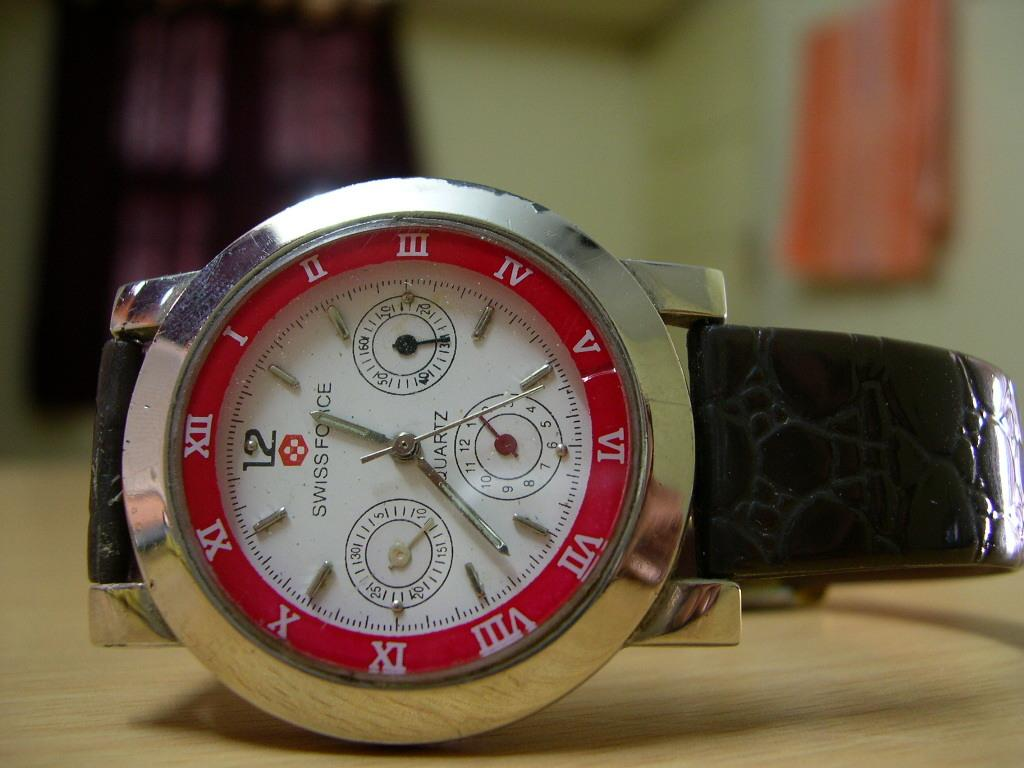<image>
Present a compact description of the photo's key features. A swiss  force quartz watch, laying on its side 